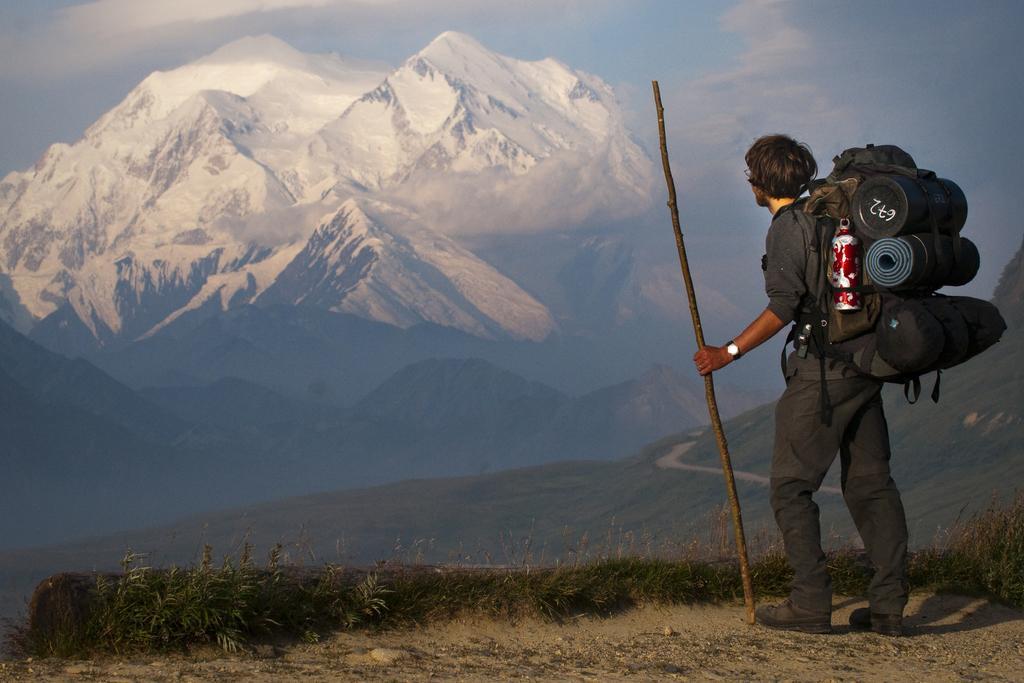Please provide a concise description of this image. In this picture we can see a person carrying a backpack and holding a stick and standing on the ground and in front of this person we can see a path, grass, mountains, plants and in the background we can see the sky with clouds. 